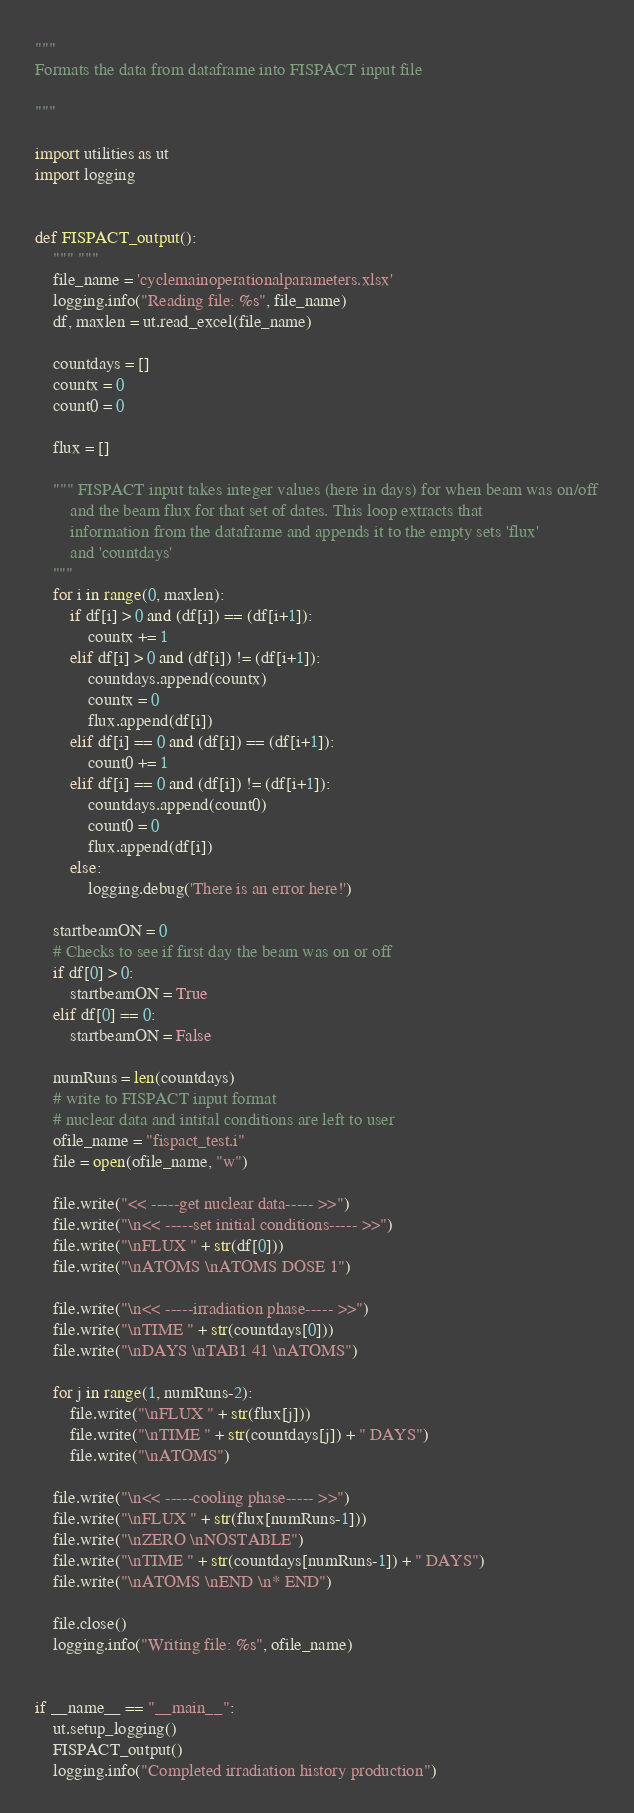Convert code to text. <code><loc_0><loc_0><loc_500><loc_500><_Python_>
"""
Formats the data from dataframe into FISPACT input file

"""

import utilities as ut
import logging


def FISPACT_output():
    """ """
    file_name = 'cyclemainoperationalparameters.xlsx'
    logging.info("Reading file: %s", file_name)
    df, maxlen = ut.read_excel(file_name)

    countdays = []
    countx = 0
    count0 = 0

    flux = []

    """ FISPACT input takes integer values (here in days) for when beam was on/off
        and the beam flux for that set of dates. This loop extracts that
        information from the dataframe and appends it to the empty sets 'flux'
        and 'countdays'
    """
    for i in range(0, maxlen):
        if df[i] > 0 and (df[i]) == (df[i+1]):
            countx += 1
        elif df[i] > 0 and (df[i]) != (df[i+1]):
            countdays.append(countx)
            countx = 0
            flux.append(df[i])
        elif df[i] == 0 and (df[i]) == (df[i+1]):
            count0 += 1
        elif df[i] == 0 and (df[i]) != (df[i+1]):
            countdays.append(count0)
            count0 = 0
            flux.append(df[i])
        else:
            logging.debug('There is an error here!')

    startbeamON = 0
    # Checks to see if first day the beam was on or off
    if df[0] > 0:
        startbeamON = True
    elif df[0] == 0:
        startbeamON = False

    numRuns = len(countdays)
    # write to FISPACT input format
    # nuclear data and intital conditions are left to user
    ofile_name = "fispact_test.i"
    file = open(ofile_name, "w")

    file.write("<< -----get nuclear data----- >>")
    file.write("\n<< -----set initial conditions----- >>")
    file.write("\nFLUX " + str(df[0]))
    file.write("\nATOMS \nATOMS DOSE 1")

    file.write("\n<< -----irradiation phase----- >>")
    file.write("\nTIME " + str(countdays[0]))
    file.write("\nDAYS \nTAB1 41 \nATOMS")

    for j in range(1, numRuns-2):
        file.write("\nFLUX " + str(flux[j]))
        file.write("\nTIME " + str(countdays[j]) + " DAYS")
        file.write("\nATOMS")

    file.write("\n<< -----cooling phase----- >>")
    file.write("\nFLUX " + str(flux[numRuns-1]))
    file.write("\nZERO \nNOSTABLE")
    file.write("\nTIME " + str(countdays[numRuns-1]) + " DAYS")
    file.write("\nATOMS \nEND \n* END")

    file.close()
    logging.info("Writing file: %s", ofile_name)


if __name__ == "__main__":
    ut.setup_logging()
    FISPACT_output()
    logging.info("Completed irradiation history production")
</code> 